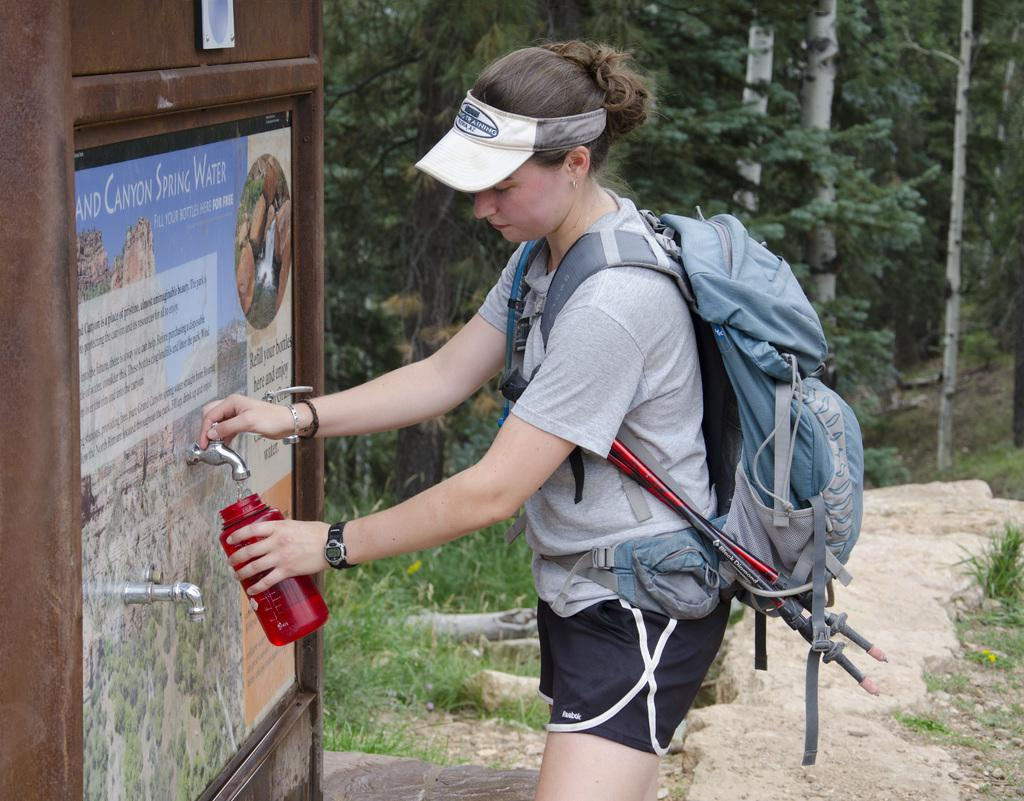What is the woman doing in the image? The woman is standing in the image and holding a tap. What else is the woman holding in her hand? The woman is also holding a water bottle in her hand. What type of bag is the woman carrying? The woman is carrying a travelling backpack. What can be seen in the background of the image? Trees are visible in the background of the image. What design is featured on the dime that the woman is holding in her hand? There is no dime present in the image, and therefore no design can be observed. How does the woman express her feelings of hate towards the trees in the background? There is no indication of hate or any negative emotions towards the trees in the image. 